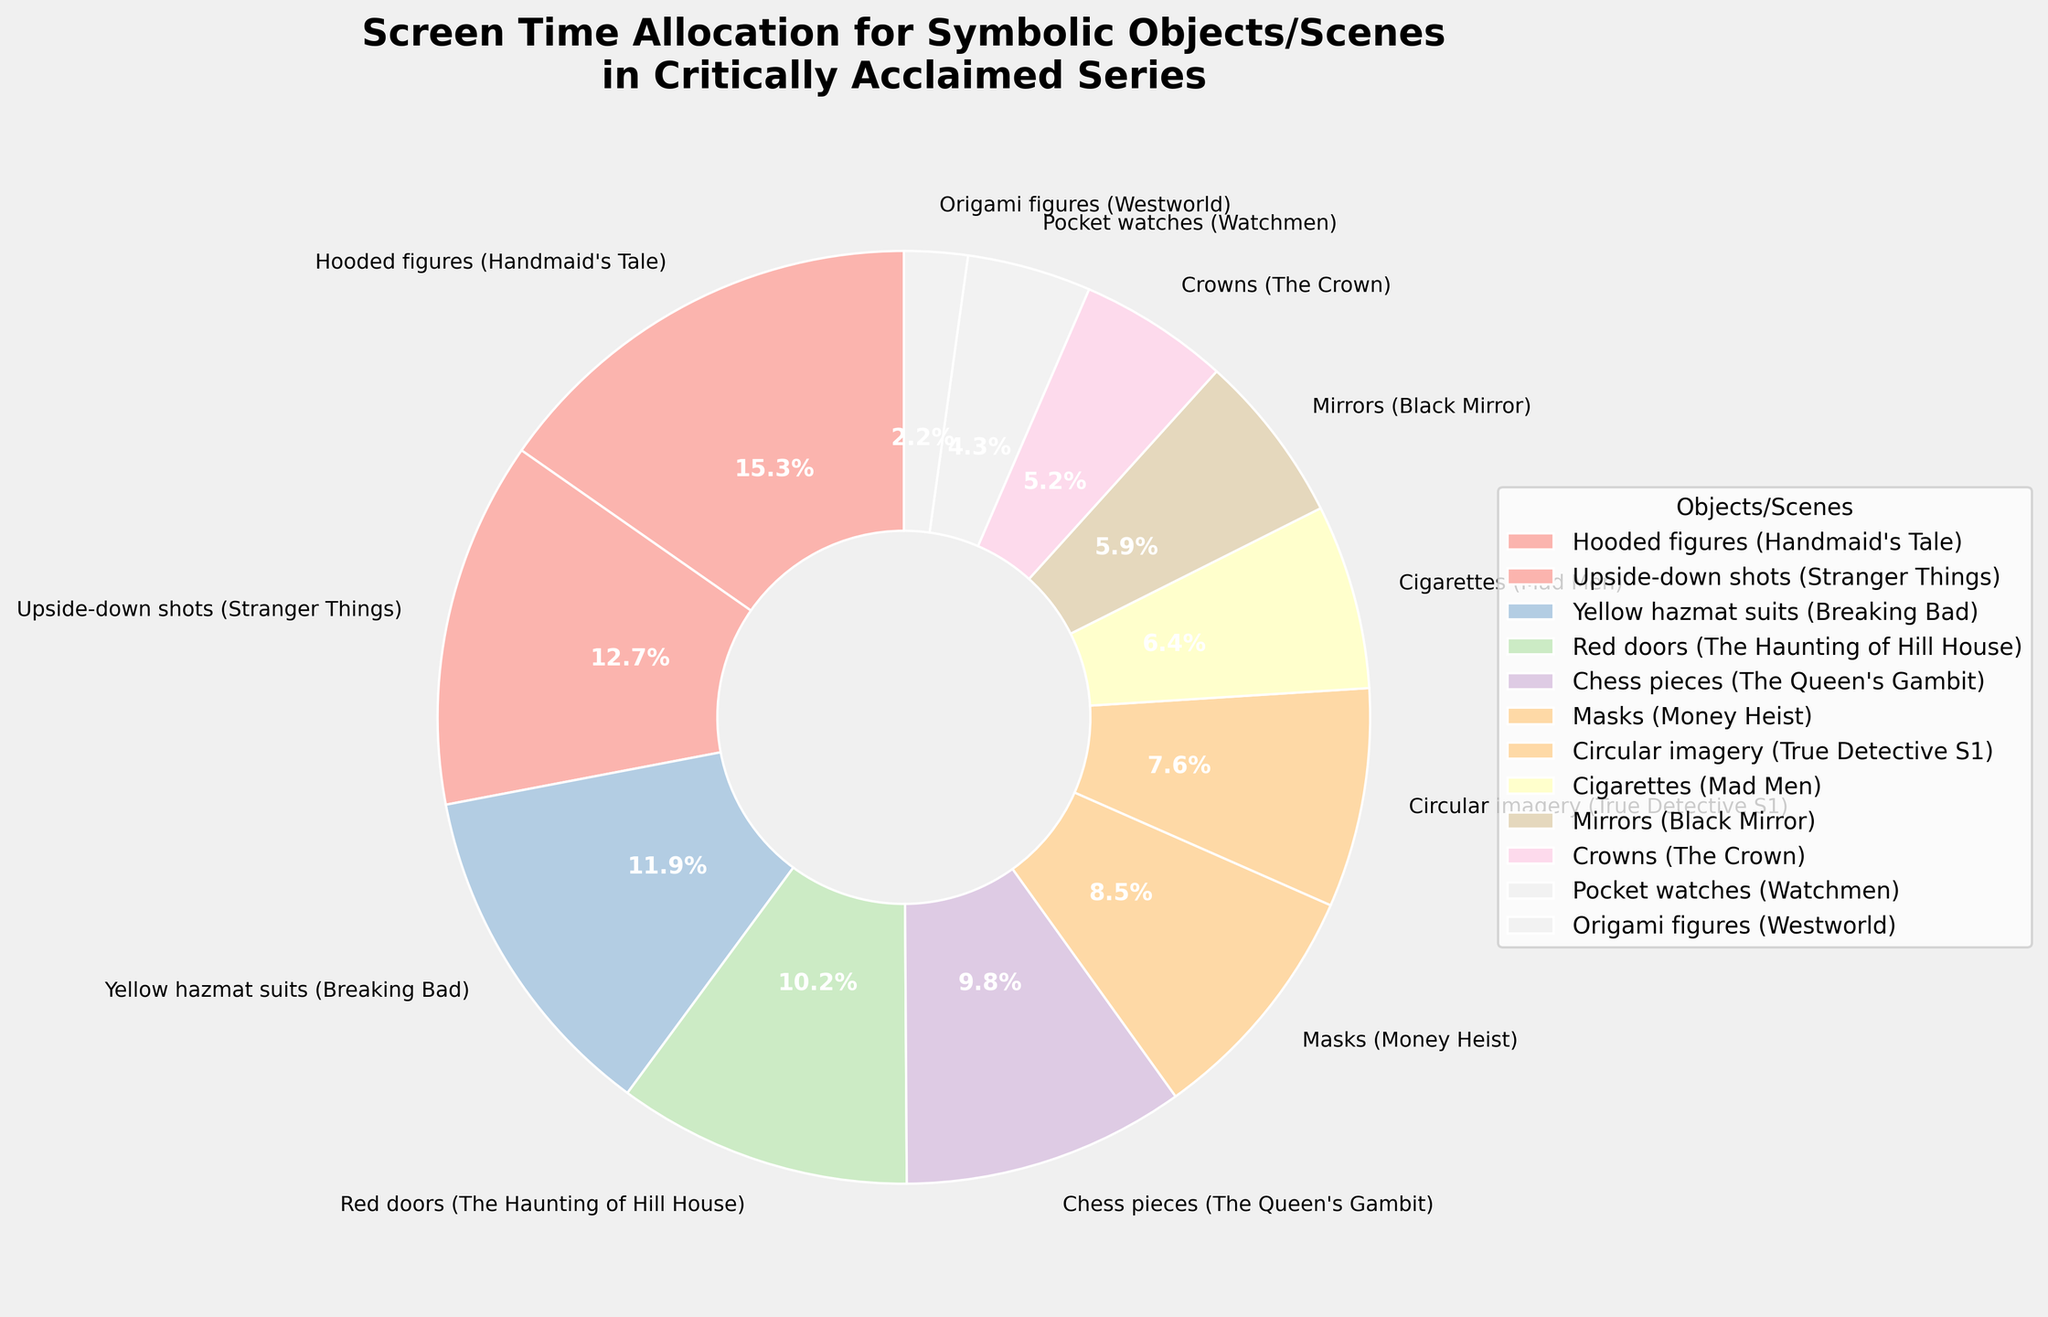What's the total screen time percentage for 'Hooded figures' in 'Handmaid's Tale' and 'Yellow hazmat suits' in 'Breaking Bad'? Add the screen time percentage of 'Hooded figures (Handmaid's Tale)' which is 15.3% and 'Yellow hazmat suits (Breaking Bad)' which is 11.9%. Therefore, 15.3 + 11.9 = 27.2.
Answer: 27.2% Which scene has a higher screen time percentage, 'Red doors' from 'The Haunting of Hill House' or 'Chess pieces' in 'The Queen's Gambit'? 'Red doors (The Haunting of Hill House)' has a screen time percentage of 10.2%, while 'Chess pieces (The Queen's Gambit)' has 9.8%. Since 10.2 > 9.8, 'Red doors' has a higher screen time percentage.
Answer: Red doors Identify the symbolic object or scene with the smallest screen time percentage and provide its value. According to the figure, 'Origami figures (Westworld)' has the smallest screen time percentage of 2.2%.
Answer: Origami figures, 2.2% Compare the screen time percentage allocation for 'Masks (Money Heist)' and 'Crowns (The Crown)' and find the difference. 'Masks (Money Heist)' has a screen time percentage of 8.5% and 'Crowns (The Crown)' has 5.2%. The difference is 8.5 - 5.2 = 3.3.
Answer: 3.3% What is the combined screen time percentage for all the symbolic objects or scenes with less than 10% allocation? The objects/scenes with less than 10% allocation are: 'Chess pieces (The Queen's Gambit)' (9.8%), 'Masks (Money Heist)' (8.5%), 'Circular imagery (True Detective S1)' (7.6%), 'Cigarettes (Mad Men)' (6.4%), 'Mirrors (Black Mirror)' (5.9%), 'Crowns (The Crown)' (5.2%), and 'Pocket watches (Watchmen)' (4.3%), 'Origami figures (Westworld)' (2.2%). Adding these values: 9.8 + 8.5 + 7.6 + 6.4 + 5.9 + 5.2 + 4.3 + 2.2 = 49.9.
Answer: 49.9% Which symbolic object/scene that appears in the plot is nearest in screen time percentage to 'Circular imagery (True Detective S1)'? 'Circular imagery (True Detective S1)' has a screen time percentage of 7.6%. The nearest value is 'Cigarettes (Mad Men)' which has 6.4%, with a difference of 1.2%.
Answer: Cigarettes What is the average screen time percentage for the top three objects/scenes? The top three objects are 'Hooded figures (Handmaid's Tale)' (15.3%), 'Upside-down shots (Stranger Things)' (12.7%), 'Yellow hazmat suits (Breaking Bad)' (11.9%). The average is (15.3 + 12.7 + 11.9) / 3 = 39.9 / 3 = 13.3.
Answer: 13.3% Is the screen time percentage for 'Red doors' in 'The Haunting of Hill House' greater than or less than twice the screen time percentage of 'Origami figures' in 'Westworld'? The screen time for 'Red doors (The Haunting of Hill House)' is 10.2%. Twice the screen time percentage of 'Origami figures (Westworld)' is 2.2 * 2 = 4.4%. Since 10.2 > 4.4, 'Red doors' has greater screen time than twice 'Origami figures'.
Answer: Greater Calculate the average screen time percentage for all objects/scenes except 'Hooded figures' from 'Handmaid's Tale'. Excluding 'Hooded figures (Handmaid's Tale)' (15.3%), calculate the average of the remaining percentages: (12.7 + 11.9 + 10.2 + 9.8 + 8.5 + 7.6 + 6.4 + 5.9 + 5.2 + 4.3 + 2.2) / 11 = 84.7 / 11 = 7.7%.
Answer: 7.7% Which two symbolic objects/scenes each contributing less than 6% can combine to have a screen time percentage closest to but not exceeding 10%? From the data: 'Origami figures (Westworld)' (2.2%), 'Pocket watches (Watchmen)' (4.3%), 'Crowns (The Crown)' (5.2%), 'Mirrors (Black Mirror)' (5.9%). Adding 'Pocket watches (Watchmen)' (4.3%) and 'Crowns (The Crown)' (5.2%) gives 4.3 + 5.2 = 9.5%, closest to but not exceeding 10%.
Answer: Pocket watches and Crowns 